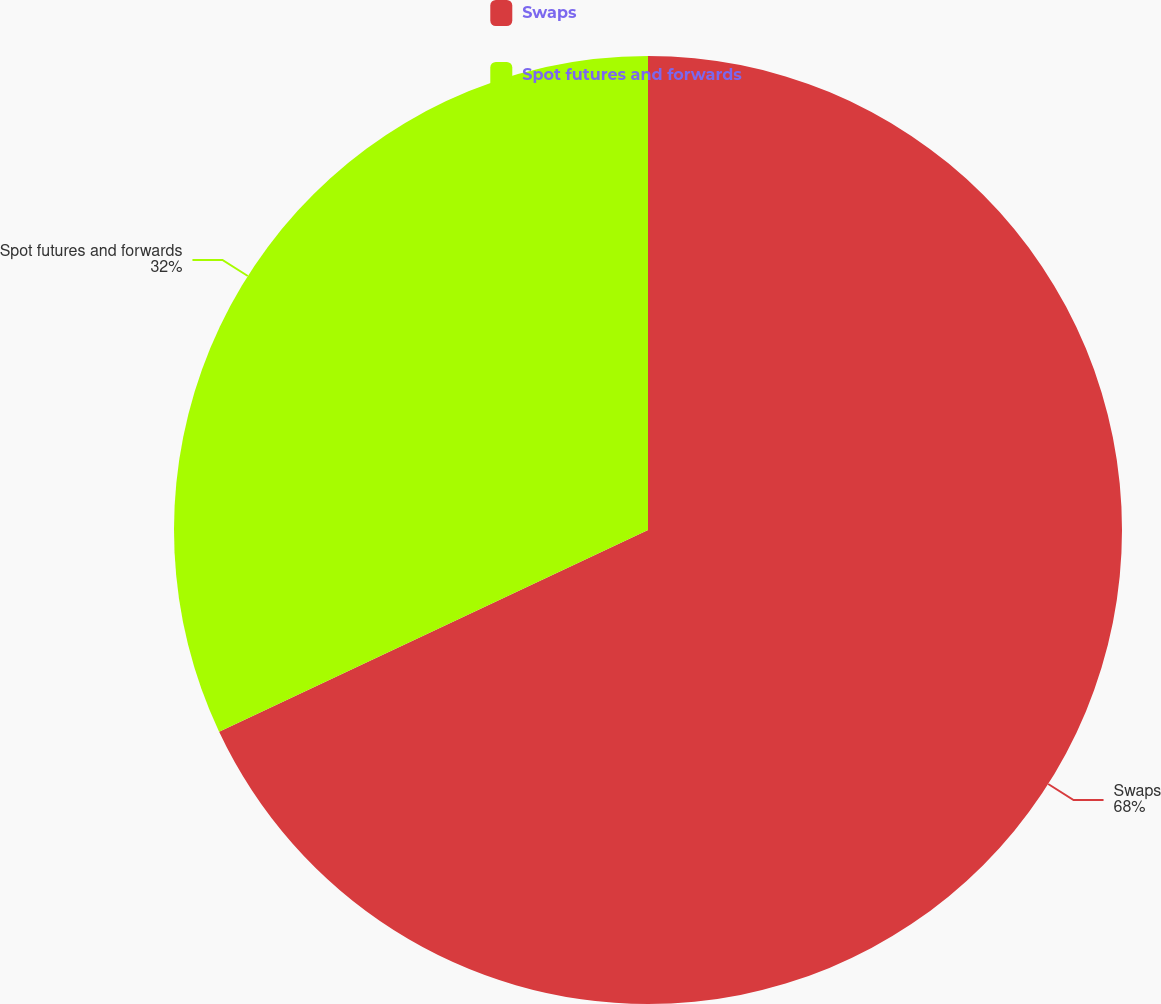Convert chart. <chart><loc_0><loc_0><loc_500><loc_500><pie_chart><fcel>Swaps<fcel>Spot futures and forwards<nl><fcel>68.0%<fcel>32.0%<nl></chart> 